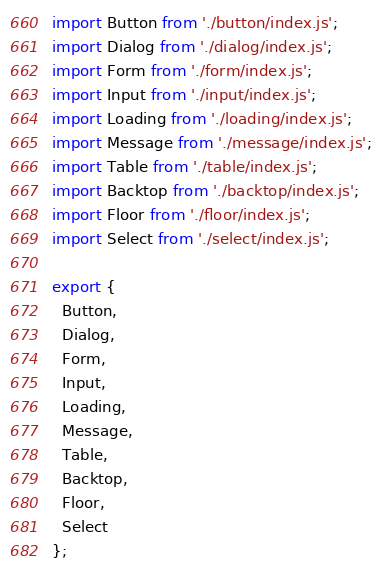Convert code to text. <code><loc_0><loc_0><loc_500><loc_500><_JavaScript_>import Button from './button/index.js';
import Dialog from './dialog/index.js';
import Form from './form/index.js';
import Input from './input/index.js';
import Loading from './loading/index.js';
import Message from './message/index.js';
import Table from './table/index.js';
import Backtop from './backtop/index.js';
import Floor from './floor/index.js';
import Select from './select/index.js';

export {
  Button,
  Dialog,
  Form,
  Input,
  Loading,
  Message,
  Table,
  Backtop,
  Floor,
  Select
};</code> 